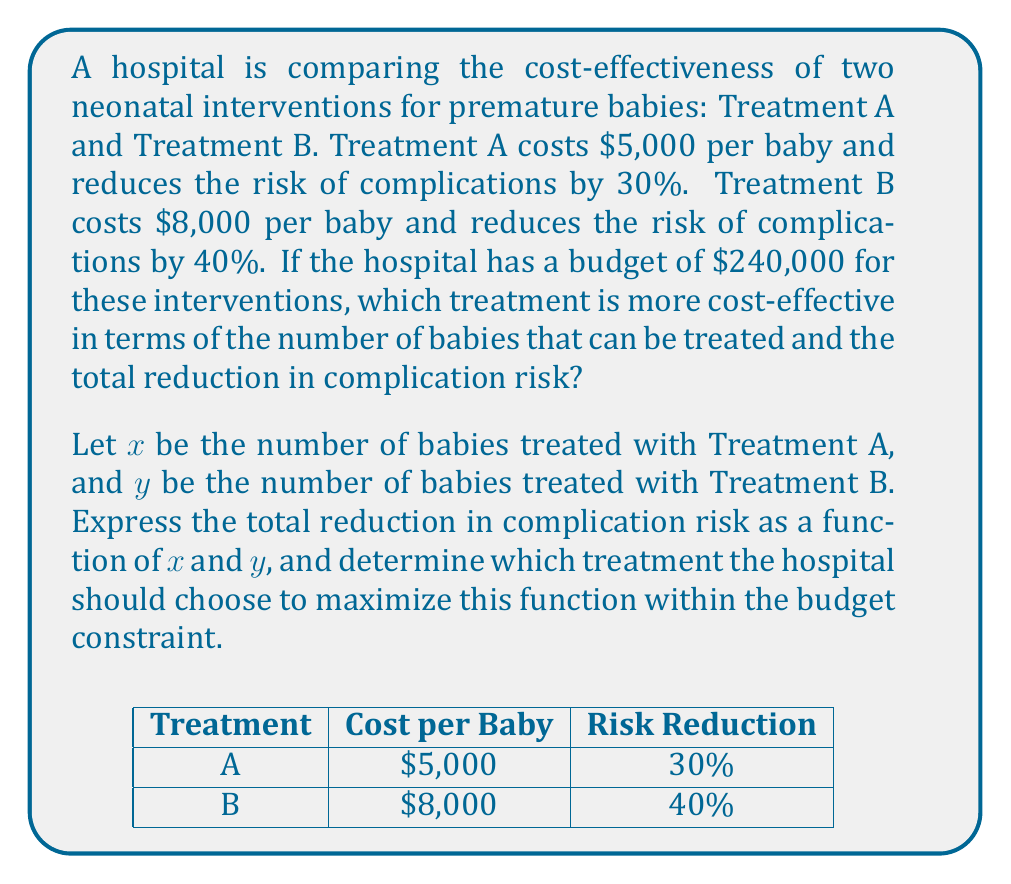Teach me how to tackle this problem. Let's approach this step-by-step:

1) First, let's set up the budget constraint equation:
   $$5000x + 8000y = 240000$$

2) We can express $y$ in terms of $x$:
   $$y = 30 - \frac{5}{8}x$$

3) Now, let's express the total reduction in complication risk as a function of $x$ and $y$:
   $$f(x,y) = 0.30x + 0.40y$$

4) Substituting $y$ with the expression from step 2:
   $$f(x) = 0.30x + 0.40(30 - \frac{5}{8}x)$$
   $$f(x) = 0.30x + 12 - 0.25x$$
   $$f(x) = 0.05x + 12$$

5) To maximize this function, we need to find the maximum value of $x$ within the constraints:
   - $x$ cannot be negative
   - $x$ cannot exceed 48 (as $240000 / 5000 = 48$)

6) Since $f(x)$ is a linear function with a positive slope, it will reach its maximum value when $x$ is at its maximum possible value, which is 48.

7) At $x = 48$:
   $$f(48) = 0.05(48) + 12 = 2.4 + 12 = 14.4$$

8) This means the hospital can treat 48 babies with Treatment A, resulting in a total risk reduction of 14.4.

9) If we chose Treatment B instead:
   Number of babies treated = $240000 / 8000 = 30$
   Total risk reduction = $0.40 * 30 = 12$

Therefore, Treatment A is more cost-effective as it allows for a higher total reduction in complication risk within the given budget.
Answer: Treatment A, with 48 babies treated and a total risk reduction of 14.4. 